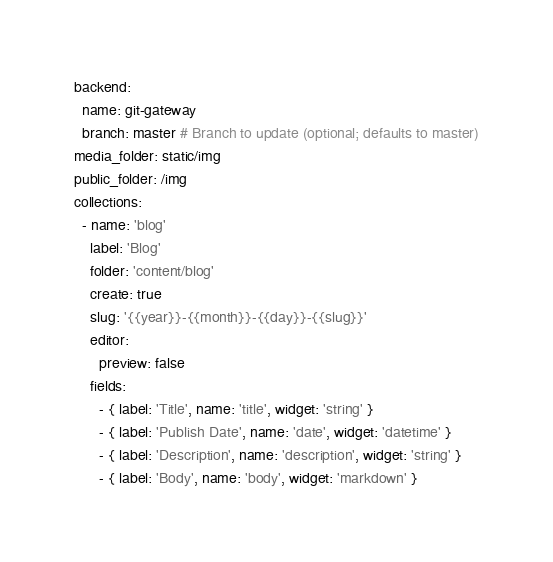<code> <loc_0><loc_0><loc_500><loc_500><_YAML_>backend:
  name: git-gateway
  branch: master # Branch to update (optional; defaults to master)
media_folder: static/img
public_folder: /img
collections:
  - name: 'blog'
    label: 'Blog'
    folder: 'content/blog'
    create: true
    slug: '{{year}}-{{month}}-{{day}}-{{slug}}'
    editor:
      preview: false
    fields:
      - { label: 'Title', name: 'title', widget: 'string' }
      - { label: 'Publish Date', name: 'date', widget: 'datetime' }
      - { label: 'Description', name: 'description', widget: 'string' }
      - { label: 'Body', name: 'body', widget: 'markdown' }


</code> 